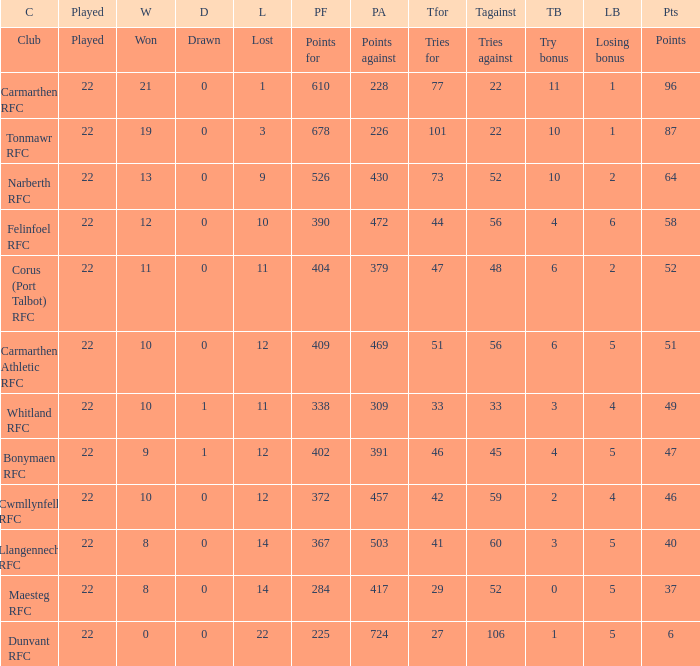Name the tries against for drawn 1.0. 